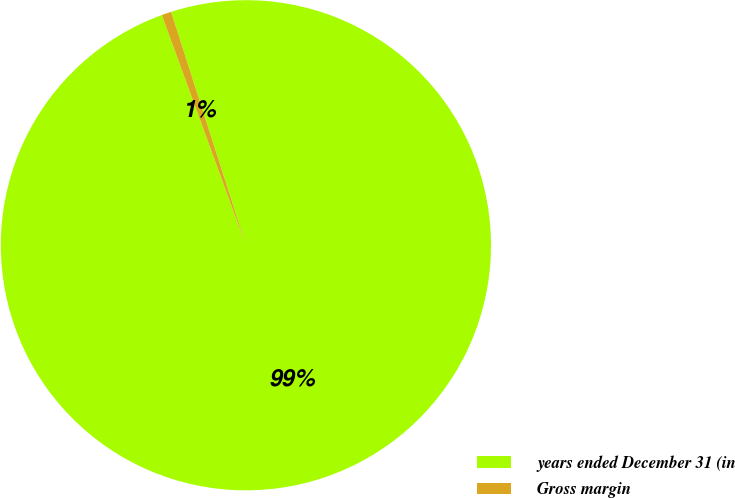Convert chart. <chart><loc_0><loc_0><loc_500><loc_500><pie_chart><fcel>years ended December 31 (in<fcel>Gross margin<nl><fcel>99.36%<fcel>0.64%<nl></chart> 